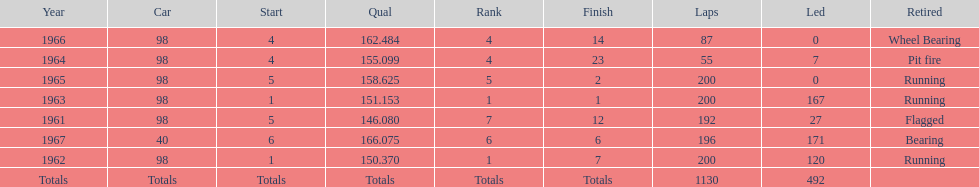In how many indy 500 races, has jones been flagged? 1. 